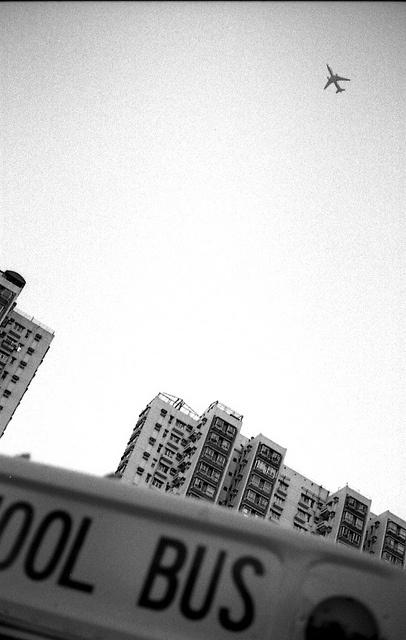Describe the objects in this image and their specific colors. I can see bus in black, gray, and gainsboro tones and airplane in black, gray, darkgray, and lightgray tones in this image. 